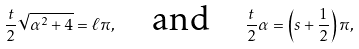Convert formula to latex. <formula><loc_0><loc_0><loc_500><loc_500>\frac { t } { 2 } \sqrt { \alpha ^ { 2 } + 4 } = \ell \pi , \quad \text {and} \quad \frac { t } { 2 } \alpha = \left ( s + \frac { 1 } { 2 } \right ) \pi ,</formula> 